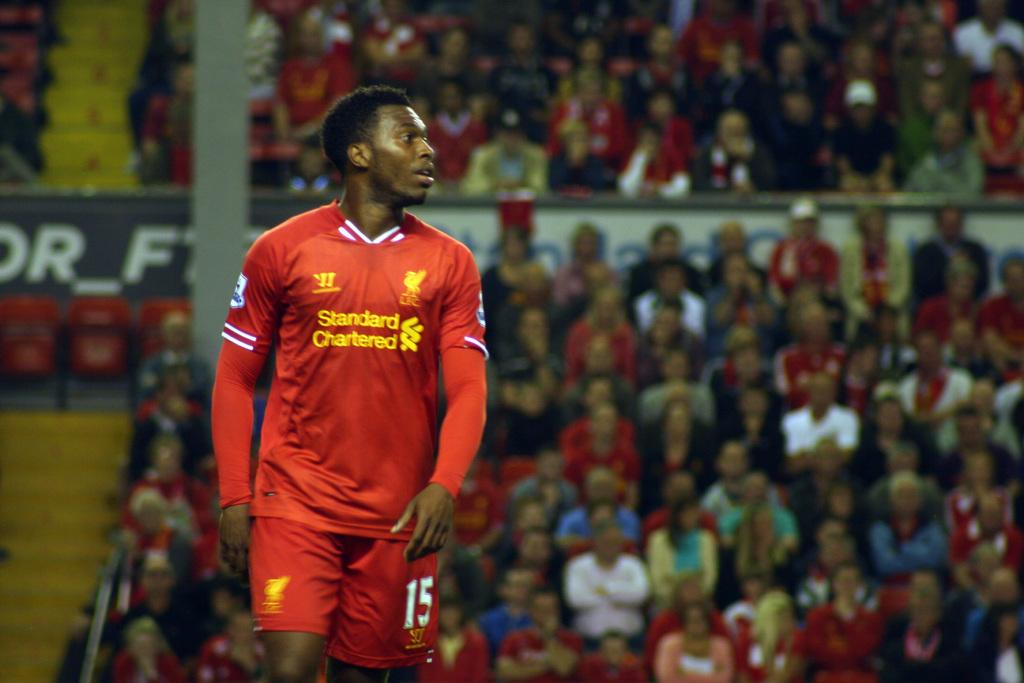<image>
Give a short and clear explanation of the subsequent image. Man wearing a red jersey with yellow letters that say Standard Chartered. 